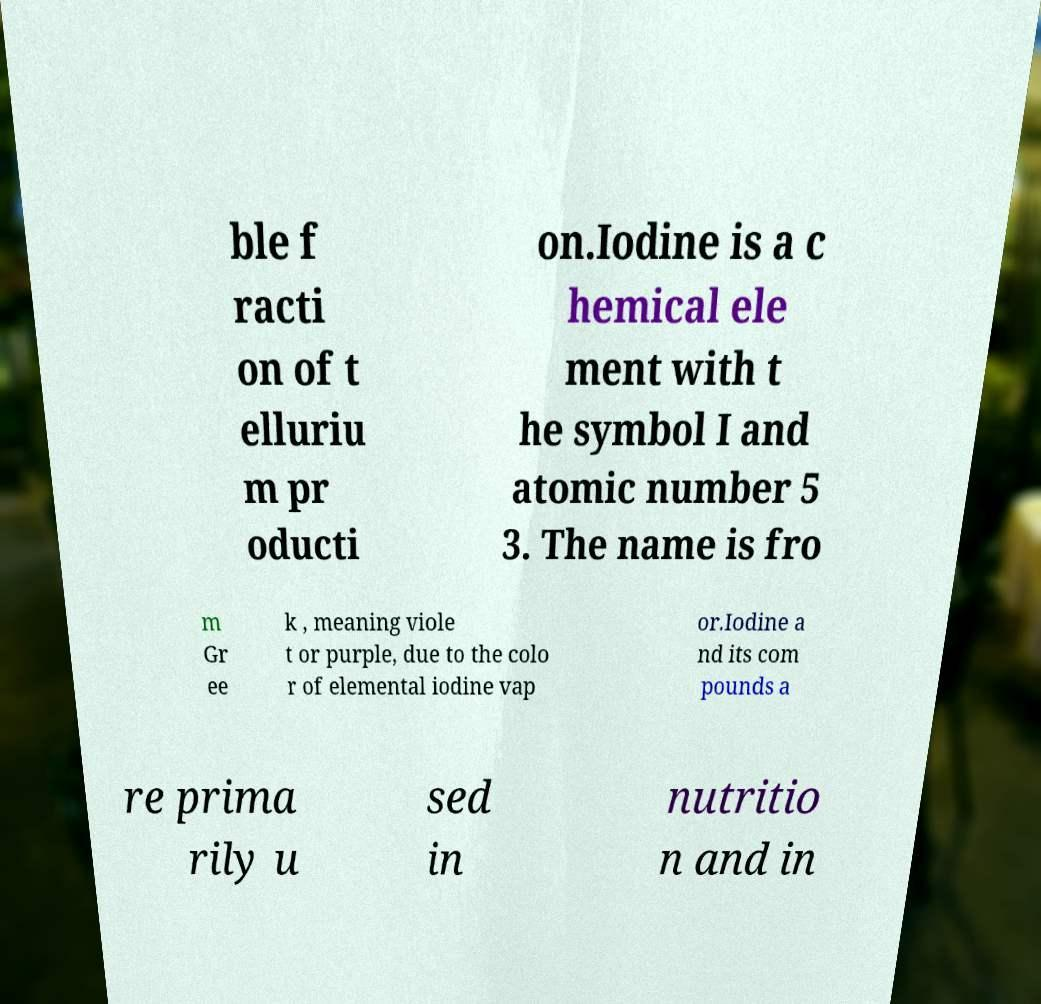Can you accurately transcribe the text from the provided image for me? ble f racti on of t elluriu m pr oducti on.Iodine is a c hemical ele ment with t he symbol I and atomic number 5 3. The name is fro m Gr ee k , meaning viole t or purple, due to the colo r of elemental iodine vap or.Iodine a nd its com pounds a re prima rily u sed in nutritio n and in 